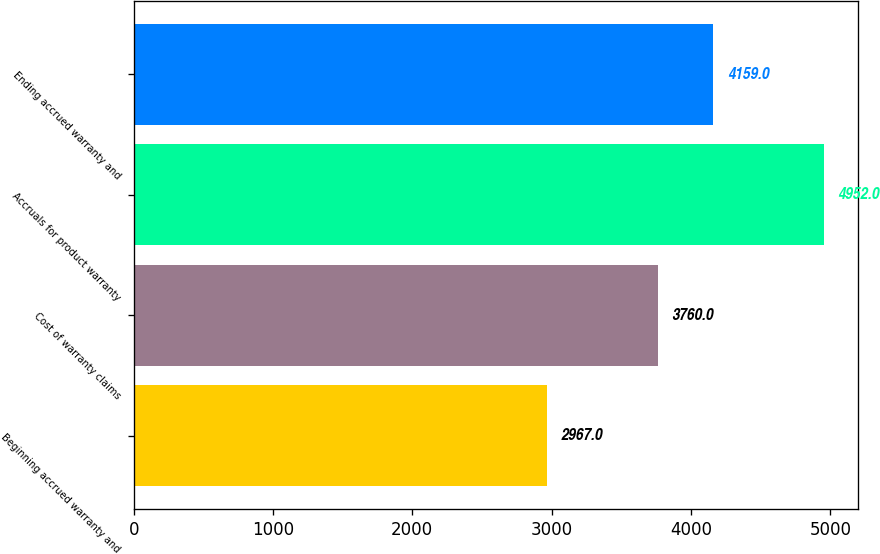Convert chart. <chart><loc_0><loc_0><loc_500><loc_500><bar_chart><fcel>Beginning accrued warranty and<fcel>Cost of warranty claims<fcel>Accruals for product warranty<fcel>Ending accrued warranty and<nl><fcel>2967<fcel>3760<fcel>4952<fcel>4159<nl></chart> 